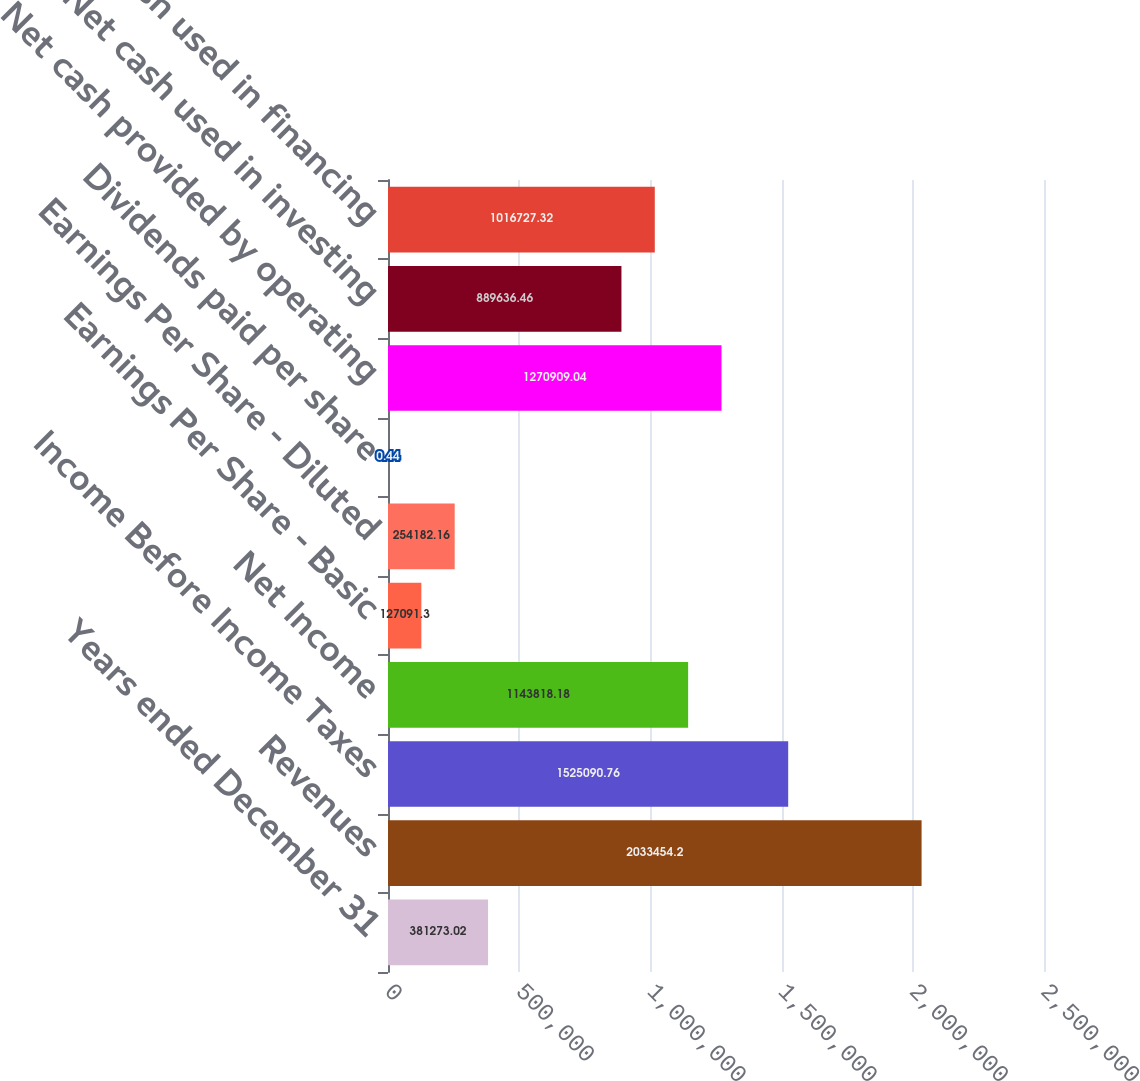<chart> <loc_0><loc_0><loc_500><loc_500><bar_chart><fcel>Years ended December 31<fcel>Revenues<fcel>Income Before Income Taxes<fcel>Net Income<fcel>Earnings Per Share - Basic<fcel>Earnings Per Share - Diluted<fcel>Dividends paid per share<fcel>Net cash provided by operating<fcel>Net cash used in investing<fcel>Net cash used in financing<nl><fcel>381273<fcel>2.03345e+06<fcel>1.52509e+06<fcel>1.14382e+06<fcel>127091<fcel>254182<fcel>0.44<fcel>1.27091e+06<fcel>889636<fcel>1.01673e+06<nl></chart> 